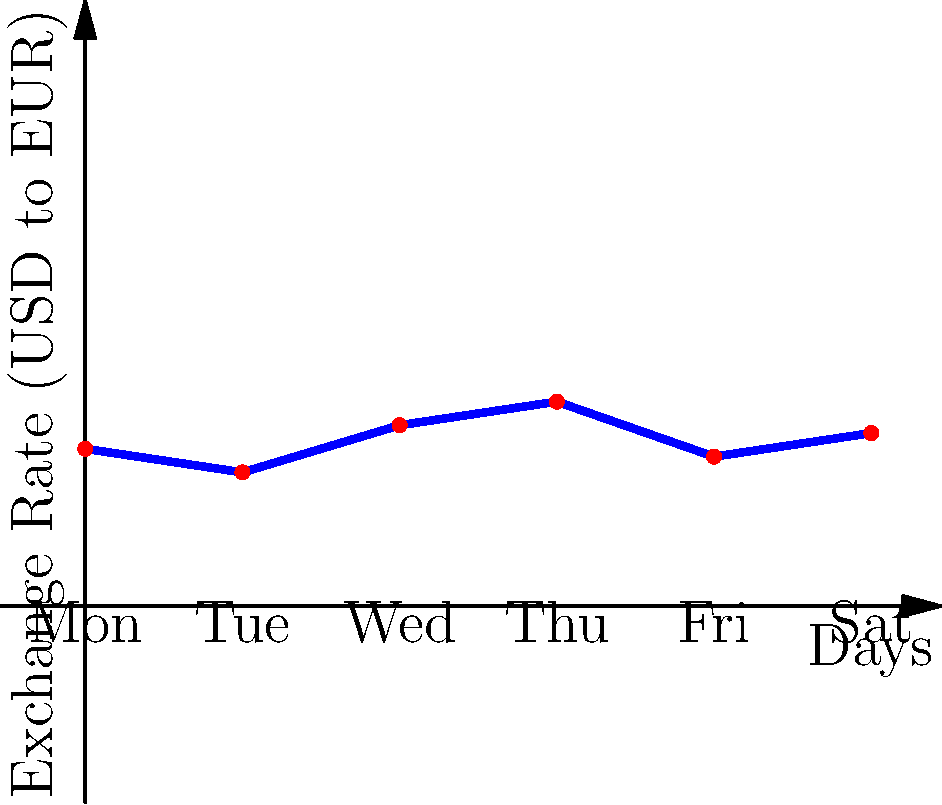As a travel blogger emphasizing online booking efficiency, you're planning a trip to Europe. The graph shows the USD to EUR exchange rate over a week. If you need to exchange $5000 for your trip, which day would be the most advantageous to make the exchange, and how many euros would you receive? To find the most advantageous day for exchange and the amount of euros received, we need to:

1. Identify the highest exchange rate from the graph:
   Monday: 1.00
   Tuesday: 0.85
   Wednesday: 1.15
   Thursday: 1.30
   Friday: 0.95
   Saturday: 1.10

   The highest rate is on Thursday at 1.30 USD to EUR.

2. Calculate the amount of euros received:
   $$ \text{Euros} = \text{USD} \times \text{Exchange Rate} $$
   $$ \text{Euros} = 5000 \times 1.30 = 6500 $$

Therefore, exchanging on Thursday would be most advantageous, yielding 6500 euros.
Answer: Thursday, 6500 euros 